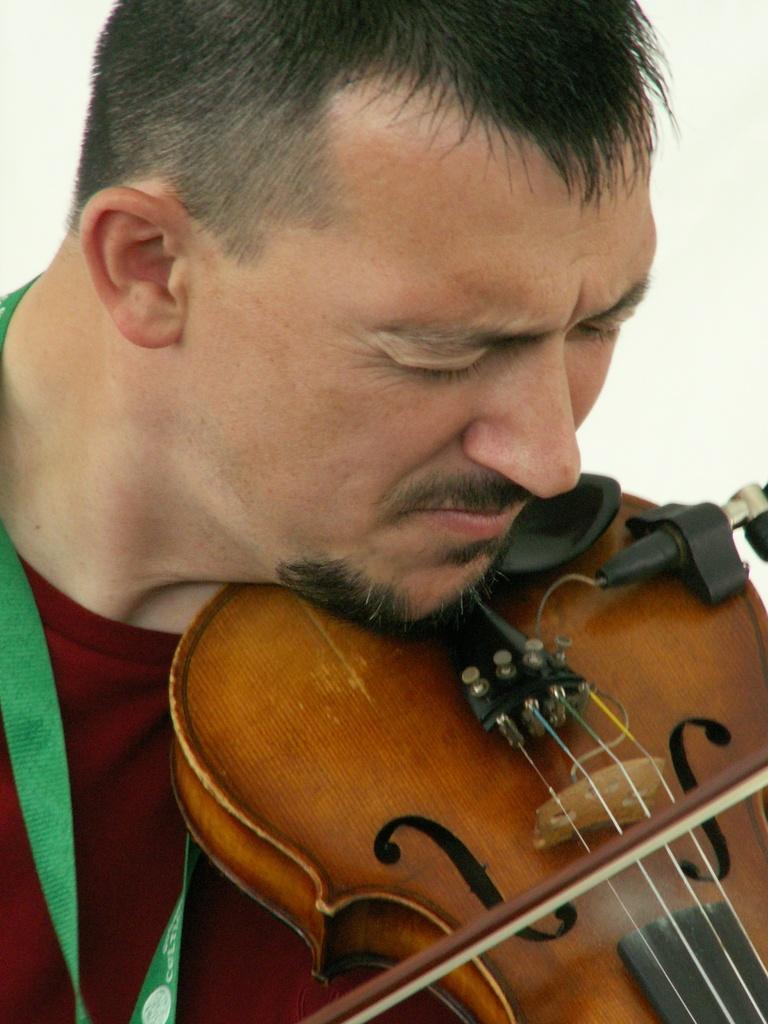Could you give a brief overview of what you see in this image? A man with red t-shirt is playing a violin. He is having a beard. 